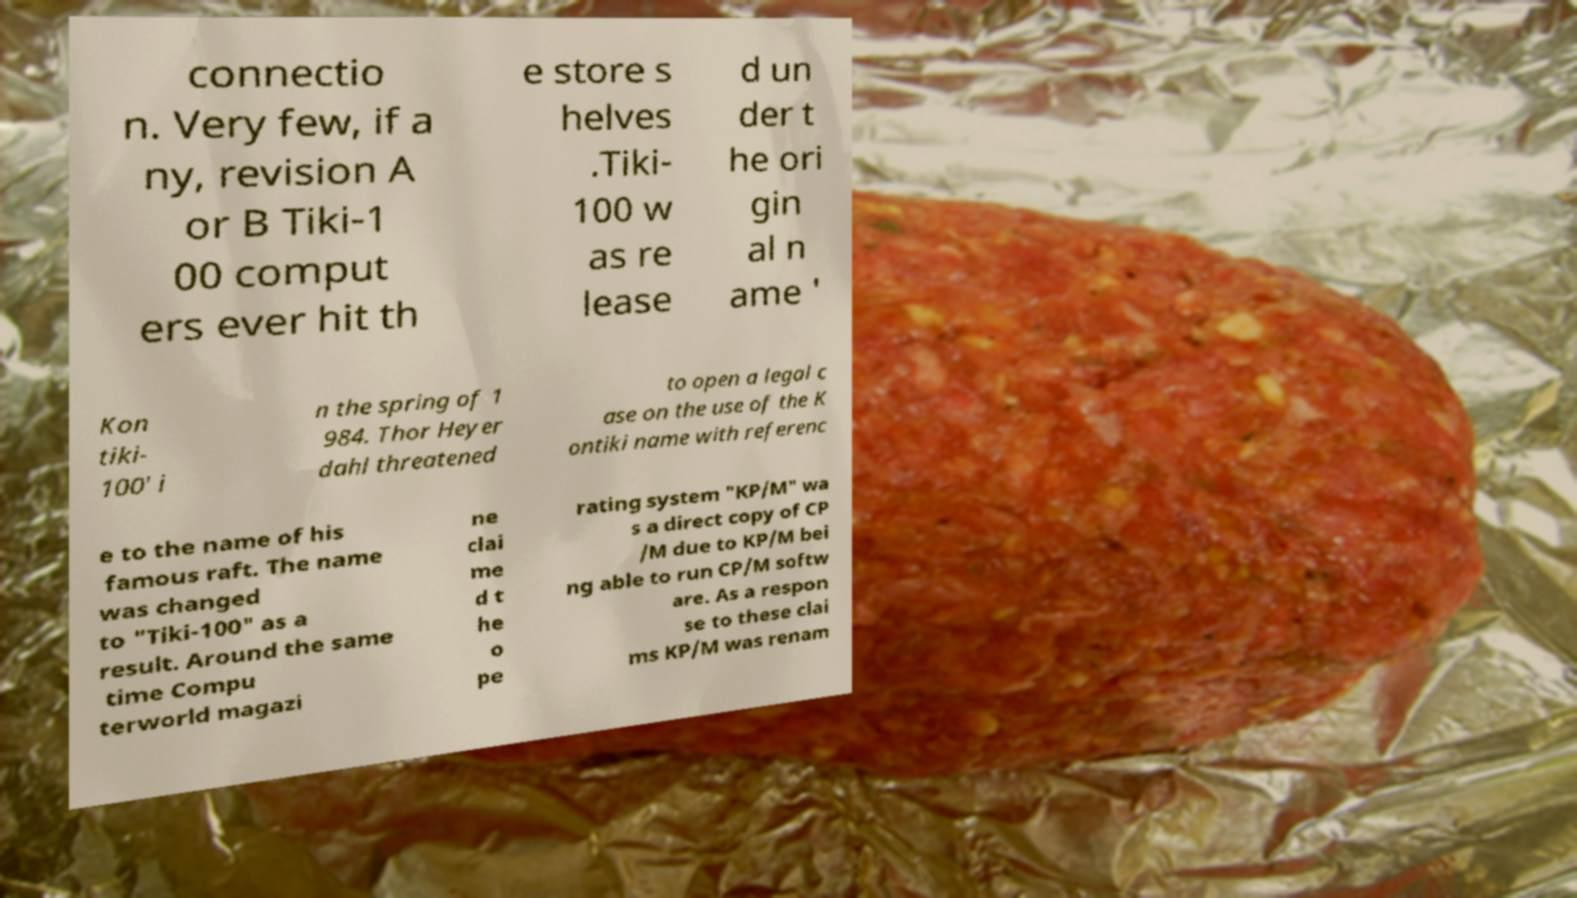Please identify and transcribe the text found in this image. connectio n. Very few, if a ny, revision A or B Tiki-1 00 comput ers ever hit th e store s helves .Tiki- 100 w as re lease d un der t he ori gin al n ame ' Kon tiki- 100' i n the spring of 1 984. Thor Heyer dahl threatened to open a legal c ase on the use of the K ontiki name with referenc e to the name of his famous raft. The name was changed to "Tiki-100" as a result. Around the same time Compu terworld magazi ne clai me d t he o pe rating system "KP/M" wa s a direct copy of CP /M due to KP/M bei ng able to run CP/M softw are. As a respon se to these clai ms KP/M was renam 